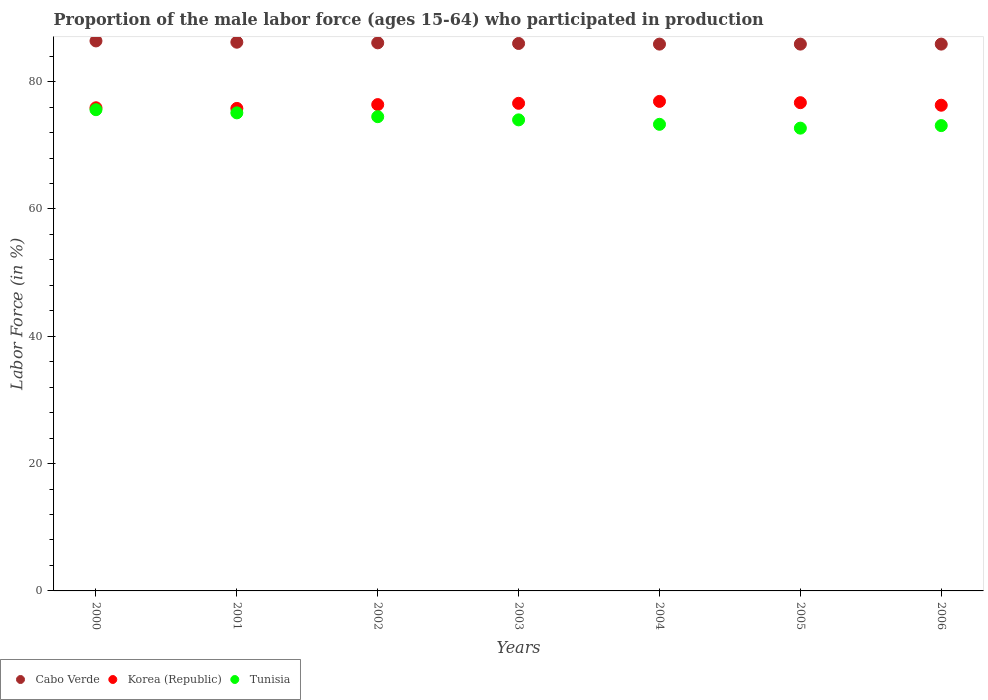Is the number of dotlines equal to the number of legend labels?
Your response must be concise. Yes. What is the proportion of the male labor force who participated in production in Tunisia in 2006?
Make the answer very short. 73.1. Across all years, what is the maximum proportion of the male labor force who participated in production in Cabo Verde?
Provide a succinct answer. 86.4. Across all years, what is the minimum proportion of the male labor force who participated in production in Korea (Republic)?
Provide a succinct answer. 75.8. What is the total proportion of the male labor force who participated in production in Tunisia in the graph?
Keep it short and to the point. 518.3. What is the difference between the proportion of the male labor force who participated in production in Cabo Verde in 2001 and that in 2006?
Your answer should be very brief. 0.3. What is the difference between the proportion of the male labor force who participated in production in Cabo Verde in 2005 and the proportion of the male labor force who participated in production in Korea (Republic) in 2000?
Provide a short and direct response. 10. What is the average proportion of the male labor force who participated in production in Tunisia per year?
Provide a short and direct response. 74.04. In the year 2004, what is the difference between the proportion of the male labor force who participated in production in Cabo Verde and proportion of the male labor force who participated in production in Korea (Republic)?
Your response must be concise. 9. In how many years, is the proportion of the male labor force who participated in production in Tunisia greater than 64 %?
Make the answer very short. 7. What is the ratio of the proportion of the male labor force who participated in production in Cabo Verde in 2000 to that in 2004?
Offer a very short reply. 1.01. What is the difference between the highest and the lowest proportion of the male labor force who participated in production in Cabo Verde?
Provide a short and direct response. 0.5. Is the sum of the proportion of the male labor force who participated in production in Tunisia in 2000 and 2004 greater than the maximum proportion of the male labor force who participated in production in Cabo Verde across all years?
Provide a short and direct response. Yes. Is it the case that in every year, the sum of the proportion of the male labor force who participated in production in Tunisia and proportion of the male labor force who participated in production in Korea (Republic)  is greater than the proportion of the male labor force who participated in production in Cabo Verde?
Make the answer very short. Yes. Is the proportion of the male labor force who participated in production in Korea (Republic) strictly less than the proportion of the male labor force who participated in production in Tunisia over the years?
Provide a succinct answer. No. How many dotlines are there?
Provide a short and direct response. 3. How many years are there in the graph?
Provide a succinct answer. 7. Are the values on the major ticks of Y-axis written in scientific E-notation?
Offer a very short reply. No. What is the title of the graph?
Provide a succinct answer. Proportion of the male labor force (ages 15-64) who participated in production. What is the label or title of the X-axis?
Provide a succinct answer. Years. What is the label or title of the Y-axis?
Give a very brief answer. Labor Force (in %). What is the Labor Force (in %) of Cabo Verde in 2000?
Offer a very short reply. 86.4. What is the Labor Force (in %) in Korea (Republic) in 2000?
Your answer should be very brief. 75.9. What is the Labor Force (in %) of Tunisia in 2000?
Provide a short and direct response. 75.6. What is the Labor Force (in %) of Cabo Verde in 2001?
Provide a short and direct response. 86.2. What is the Labor Force (in %) of Korea (Republic) in 2001?
Your answer should be compact. 75.8. What is the Labor Force (in %) in Tunisia in 2001?
Make the answer very short. 75.1. What is the Labor Force (in %) in Cabo Verde in 2002?
Provide a succinct answer. 86.1. What is the Labor Force (in %) in Korea (Republic) in 2002?
Offer a terse response. 76.4. What is the Labor Force (in %) of Tunisia in 2002?
Offer a very short reply. 74.5. What is the Labor Force (in %) in Korea (Republic) in 2003?
Your answer should be very brief. 76.6. What is the Labor Force (in %) in Tunisia in 2003?
Provide a short and direct response. 74. What is the Labor Force (in %) in Cabo Verde in 2004?
Keep it short and to the point. 85.9. What is the Labor Force (in %) of Korea (Republic) in 2004?
Give a very brief answer. 76.9. What is the Labor Force (in %) in Tunisia in 2004?
Keep it short and to the point. 73.3. What is the Labor Force (in %) in Cabo Verde in 2005?
Your answer should be very brief. 85.9. What is the Labor Force (in %) in Korea (Republic) in 2005?
Your answer should be very brief. 76.7. What is the Labor Force (in %) in Tunisia in 2005?
Ensure brevity in your answer.  72.7. What is the Labor Force (in %) in Cabo Verde in 2006?
Provide a short and direct response. 85.9. What is the Labor Force (in %) of Korea (Republic) in 2006?
Ensure brevity in your answer.  76.3. What is the Labor Force (in %) in Tunisia in 2006?
Offer a very short reply. 73.1. Across all years, what is the maximum Labor Force (in %) of Cabo Verde?
Offer a very short reply. 86.4. Across all years, what is the maximum Labor Force (in %) of Korea (Republic)?
Offer a terse response. 76.9. Across all years, what is the maximum Labor Force (in %) in Tunisia?
Your response must be concise. 75.6. Across all years, what is the minimum Labor Force (in %) in Cabo Verde?
Give a very brief answer. 85.9. Across all years, what is the minimum Labor Force (in %) of Korea (Republic)?
Make the answer very short. 75.8. Across all years, what is the minimum Labor Force (in %) in Tunisia?
Your response must be concise. 72.7. What is the total Labor Force (in %) of Cabo Verde in the graph?
Your answer should be very brief. 602.4. What is the total Labor Force (in %) in Korea (Republic) in the graph?
Provide a short and direct response. 534.6. What is the total Labor Force (in %) of Tunisia in the graph?
Your answer should be compact. 518.3. What is the difference between the Labor Force (in %) in Cabo Verde in 2000 and that in 2002?
Provide a short and direct response. 0.3. What is the difference between the Labor Force (in %) of Korea (Republic) in 2000 and that in 2002?
Provide a succinct answer. -0.5. What is the difference between the Labor Force (in %) of Tunisia in 2000 and that in 2002?
Offer a terse response. 1.1. What is the difference between the Labor Force (in %) in Cabo Verde in 2000 and that in 2004?
Offer a terse response. 0.5. What is the difference between the Labor Force (in %) in Tunisia in 2000 and that in 2004?
Offer a very short reply. 2.3. What is the difference between the Labor Force (in %) in Korea (Republic) in 2000 and that in 2005?
Your answer should be compact. -0.8. What is the difference between the Labor Force (in %) in Tunisia in 2000 and that in 2005?
Make the answer very short. 2.9. What is the difference between the Labor Force (in %) of Cabo Verde in 2000 and that in 2006?
Make the answer very short. 0.5. What is the difference between the Labor Force (in %) in Cabo Verde in 2001 and that in 2002?
Your answer should be compact. 0.1. What is the difference between the Labor Force (in %) of Korea (Republic) in 2001 and that in 2002?
Your answer should be very brief. -0.6. What is the difference between the Labor Force (in %) in Cabo Verde in 2001 and that in 2003?
Ensure brevity in your answer.  0.2. What is the difference between the Labor Force (in %) in Korea (Republic) in 2001 and that in 2003?
Offer a very short reply. -0.8. What is the difference between the Labor Force (in %) in Cabo Verde in 2001 and that in 2004?
Your answer should be very brief. 0.3. What is the difference between the Labor Force (in %) of Korea (Republic) in 2001 and that in 2004?
Offer a very short reply. -1.1. What is the difference between the Labor Force (in %) in Korea (Republic) in 2001 and that in 2005?
Make the answer very short. -0.9. What is the difference between the Labor Force (in %) in Tunisia in 2001 and that in 2005?
Provide a short and direct response. 2.4. What is the difference between the Labor Force (in %) in Korea (Republic) in 2001 and that in 2006?
Give a very brief answer. -0.5. What is the difference between the Labor Force (in %) of Tunisia in 2001 and that in 2006?
Make the answer very short. 2. What is the difference between the Labor Force (in %) in Korea (Republic) in 2002 and that in 2003?
Ensure brevity in your answer.  -0.2. What is the difference between the Labor Force (in %) of Korea (Republic) in 2002 and that in 2004?
Your answer should be compact. -0.5. What is the difference between the Labor Force (in %) in Tunisia in 2002 and that in 2004?
Keep it short and to the point. 1.2. What is the difference between the Labor Force (in %) in Cabo Verde in 2002 and that in 2005?
Keep it short and to the point. 0.2. What is the difference between the Labor Force (in %) in Korea (Republic) in 2002 and that in 2005?
Provide a succinct answer. -0.3. What is the difference between the Labor Force (in %) in Tunisia in 2002 and that in 2005?
Your answer should be very brief. 1.8. What is the difference between the Labor Force (in %) of Cabo Verde in 2002 and that in 2006?
Your answer should be very brief. 0.2. What is the difference between the Labor Force (in %) of Korea (Republic) in 2002 and that in 2006?
Offer a terse response. 0.1. What is the difference between the Labor Force (in %) of Cabo Verde in 2003 and that in 2004?
Give a very brief answer. 0.1. What is the difference between the Labor Force (in %) in Korea (Republic) in 2003 and that in 2004?
Make the answer very short. -0.3. What is the difference between the Labor Force (in %) in Tunisia in 2003 and that in 2004?
Provide a succinct answer. 0.7. What is the difference between the Labor Force (in %) of Tunisia in 2003 and that in 2005?
Provide a short and direct response. 1.3. What is the difference between the Labor Force (in %) in Korea (Republic) in 2003 and that in 2006?
Make the answer very short. 0.3. What is the difference between the Labor Force (in %) in Cabo Verde in 2004 and that in 2005?
Keep it short and to the point. 0. What is the difference between the Labor Force (in %) of Tunisia in 2004 and that in 2005?
Provide a short and direct response. 0.6. What is the difference between the Labor Force (in %) of Cabo Verde in 2004 and that in 2006?
Your response must be concise. 0. What is the difference between the Labor Force (in %) of Korea (Republic) in 2000 and the Labor Force (in %) of Tunisia in 2001?
Your answer should be very brief. 0.8. What is the difference between the Labor Force (in %) in Cabo Verde in 2000 and the Labor Force (in %) in Korea (Republic) in 2002?
Provide a short and direct response. 10. What is the difference between the Labor Force (in %) in Cabo Verde in 2000 and the Labor Force (in %) in Tunisia in 2002?
Provide a short and direct response. 11.9. What is the difference between the Labor Force (in %) in Cabo Verde in 2000 and the Labor Force (in %) in Korea (Republic) in 2004?
Make the answer very short. 9.5. What is the difference between the Labor Force (in %) in Korea (Republic) in 2000 and the Labor Force (in %) in Tunisia in 2005?
Provide a succinct answer. 3.2. What is the difference between the Labor Force (in %) in Cabo Verde in 2000 and the Labor Force (in %) in Korea (Republic) in 2006?
Your response must be concise. 10.1. What is the difference between the Labor Force (in %) of Korea (Republic) in 2000 and the Labor Force (in %) of Tunisia in 2006?
Make the answer very short. 2.8. What is the difference between the Labor Force (in %) of Cabo Verde in 2001 and the Labor Force (in %) of Tunisia in 2002?
Give a very brief answer. 11.7. What is the difference between the Labor Force (in %) in Cabo Verde in 2001 and the Labor Force (in %) in Tunisia in 2003?
Make the answer very short. 12.2. What is the difference between the Labor Force (in %) in Korea (Republic) in 2001 and the Labor Force (in %) in Tunisia in 2003?
Provide a short and direct response. 1.8. What is the difference between the Labor Force (in %) in Cabo Verde in 2001 and the Labor Force (in %) in Korea (Republic) in 2004?
Your response must be concise. 9.3. What is the difference between the Labor Force (in %) in Cabo Verde in 2001 and the Labor Force (in %) in Tunisia in 2004?
Make the answer very short. 12.9. What is the difference between the Labor Force (in %) of Korea (Republic) in 2001 and the Labor Force (in %) of Tunisia in 2005?
Give a very brief answer. 3.1. What is the difference between the Labor Force (in %) of Cabo Verde in 2001 and the Labor Force (in %) of Korea (Republic) in 2006?
Your answer should be compact. 9.9. What is the difference between the Labor Force (in %) in Cabo Verde in 2001 and the Labor Force (in %) in Tunisia in 2006?
Offer a terse response. 13.1. What is the difference between the Labor Force (in %) in Korea (Republic) in 2001 and the Labor Force (in %) in Tunisia in 2006?
Your answer should be very brief. 2.7. What is the difference between the Labor Force (in %) in Cabo Verde in 2002 and the Labor Force (in %) in Korea (Republic) in 2003?
Your answer should be very brief. 9.5. What is the difference between the Labor Force (in %) in Cabo Verde in 2002 and the Labor Force (in %) in Korea (Republic) in 2004?
Offer a very short reply. 9.2. What is the difference between the Labor Force (in %) in Cabo Verde in 2002 and the Labor Force (in %) in Tunisia in 2004?
Your response must be concise. 12.8. What is the difference between the Labor Force (in %) of Korea (Republic) in 2002 and the Labor Force (in %) of Tunisia in 2004?
Keep it short and to the point. 3.1. What is the difference between the Labor Force (in %) of Cabo Verde in 2002 and the Labor Force (in %) of Tunisia in 2005?
Ensure brevity in your answer.  13.4. What is the difference between the Labor Force (in %) in Korea (Republic) in 2002 and the Labor Force (in %) in Tunisia in 2005?
Keep it short and to the point. 3.7. What is the difference between the Labor Force (in %) in Cabo Verde in 2003 and the Labor Force (in %) in Tunisia in 2004?
Provide a short and direct response. 12.7. What is the difference between the Labor Force (in %) of Korea (Republic) in 2003 and the Labor Force (in %) of Tunisia in 2004?
Your response must be concise. 3.3. What is the difference between the Labor Force (in %) of Korea (Republic) in 2003 and the Labor Force (in %) of Tunisia in 2005?
Your answer should be very brief. 3.9. What is the difference between the Labor Force (in %) of Cabo Verde in 2003 and the Labor Force (in %) of Korea (Republic) in 2006?
Your response must be concise. 9.7. What is the difference between the Labor Force (in %) in Cabo Verde in 2003 and the Labor Force (in %) in Tunisia in 2006?
Your answer should be compact. 12.9. What is the difference between the Labor Force (in %) of Korea (Republic) in 2004 and the Labor Force (in %) of Tunisia in 2005?
Offer a very short reply. 4.2. What is the difference between the Labor Force (in %) of Cabo Verde in 2004 and the Labor Force (in %) of Korea (Republic) in 2006?
Your answer should be very brief. 9.6. What is the difference between the Labor Force (in %) in Cabo Verde in 2004 and the Labor Force (in %) in Tunisia in 2006?
Your answer should be very brief. 12.8. What is the average Labor Force (in %) of Cabo Verde per year?
Your answer should be compact. 86.06. What is the average Labor Force (in %) of Korea (Republic) per year?
Provide a short and direct response. 76.37. What is the average Labor Force (in %) of Tunisia per year?
Provide a short and direct response. 74.04. In the year 2000, what is the difference between the Labor Force (in %) of Cabo Verde and Labor Force (in %) of Korea (Republic)?
Give a very brief answer. 10.5. In the year 2001, what is the difference between the Labor Force (in %) in Cabo Verde and Labor Force (in %) in Korea (Republic)?
Offer a very short reply. 10.4. In the year 2001, what is the difference between the Labor Force (in %) of Korea (Republic) and Labor Force (in %) of Tunisia?
Ensure brevity in your answer.  0.7. In the year 2002, what is the difference between the Labor Force (in %) of Cabo Verde and Labor Force (in %) of Korea (Republic)?
Your answer should be compact. 9.7. In the year 2002, what is the difference between the Labor Force (in %) of Korea (Republic) and Labor Force (in %) of Tunisia?
Offer a very short reply. 1.9. In the year 2003, what is the difference between the Labor Force (in %) in Cabo Verde and Labor Force (in %) in Korea (Republic)?
Provide a succinct answer. 9.4. In the year 2003, what is the difference between the Labor Force (in %) in Korea (Republic) and Labor Force (in %) in Tunisia?
Offer a terse response. 2.6. In the year 2004, what is the difference between the Labor Force (in %) of Korea (Republic) and Labor Force (in %) of Tunisia?
Provide a short and direct response. 3.6. In the year 2005, what is the difference between the Labor Force (in %) of Cabo Verde and Labor Force (in %) of Korea (Republic)?
Offer a very short reply. 9.2. In the year 2005, what is the difference between the Labor Force (in %) in Korea (Republic) and Labor Force (in %) in Tunisia?
Your answer should be compact. 4. In the year 2006, what is the difference between the Labor Force (in %) of Cabo Verde and Labor Force (in %) of Korea (Republic)?
Keep it short and to the point. 9.6. In the year 2006, what is the difference between the Labor Force (in %) of Korea (Republic) and Labor Force (in %) of Tunisia?
Your answer should be very brief. 3.2. What is the ratio of the Labor Force (in %) in Cabo Verde in 2000 to that in 2001?
Provide a succinct answer. 1. What is the ratio of the Labor Force (in %) of Korea (Republic) in 2000 to that in 2001?
Give a very brief answer. 1. What is the ratio of the Labor Force (in %) in Tunisia in 2000 to that in 2001?
Give a very brief answer. 1.01. What is the ratio of the Labor Force (in %) of Korea (Republic) in 2000 to that in 2002?
Make the answer very short. 0.99. What is the ratio of the Labor Force (in %) of Tunisia in 2000 to that in 2002?
Provide a succinct answer. 1.01. What is the ratio of the Labor Force (in %) in Cabo Verde in 2000 to that in 2003?
Make the answer very short. 1. What is the ratio of the Labor Force (in %) in Korea (Republic) in 2000 to that in 2003?
Your response must be concise. 0.99. What is the ratio of the Labor Force (in %) in Tunisia in 2000 to that in 2003?
Your response must be concise. 1.02. What is the ratio of the Labor Force (in %) of Cabo Verde in 2000 to that in 2004?
Offer a terse response. 1.01. What is the ratio of the Labor Force (in %) in Tunisia in 2000 to that in 2004?
Offer a very short reply. 1.03. What is the ratio of the Labor Force (in %) of Korea (Republic) in 2000 to that in 2005?
Offer a terse response. 0.99. What is the ratio of the Labor Force (in %) in Tunisia in 2000 to that in 2005?
Your response must be concise. 1.04. What is the ratio of the Labor Force (in %) in Tunisia in 2000 to that in 2006?
Your response must be concise. 1.03. What is the ratio of the Labor Force (in %) in Korea (Republic) in 2001 to that in 2002?
Your answer should be very brief. 0.99. What is the ratio of the Labor Force (in %) in Tunisia in 2001 to that in 2002?
Make the answer very short. 1.01. What is the ratio of the Labor Force (in %) of Cabo Verde in 2001 to that in 2003?
Your response must be concise. 1. What is the ratio of the Labor Force (in %) in Korea (Republic) in 2001 to that in 2003?
Offer a terse response. 0.99. What is the ratio of the Labor Force (in %) of Tunisia in 2001 to that in 2003?
Offer a very short reply. 1.01. What is the ratio of the Labor Force (in %) in Cabo Verde in 2001 to that in 2004?
Ensure brevity in your answer.  1. What is the ratio of the Labor Force (in %) in Korea (Republic) in 2001 to that in 2004?
Keep it short and to the point. 0.99. What is the ratio of the Labor Force (in %) of Tunisia in 2001 to that in 2004?
Provide a succinct answer. 1.02. What is the ratio of the Labor Force (in %) in Cabo Verde in 2001 to that in 2005?
Your answer should be compact. 1. What is the ratio of the Labor Force (in %) in Korea (Republic) in 2001 to that in 2005?
Your answer should be compact. 0.99. What is the ratio of the Labor Force (in %) of Tunisia in 2001 to that in 2005?
Your answer should be compact. 1.03. What is the ratio of the Labor Force (in %) in Cabo Verde in 2001 to that in 2006?
Your answer should be very brief. 1. What is the ratio of the Labor Force (in %) in Tunisia in 2001 to that in 2006?
Provide a short and direct response. 1.03. What is the ratio of the Labor Force (in %) in Cabo Verde in 2002 to that in 2003?
Provide a succinct answer. 1. What is the ratio of the Labor Force (in %) in Korea (Republic) in 2002 to that in 2003?
Ensure brevity in your answer.  1. What is the ratio of the Labor Force (in %) in Tunisia in 2002 to that in 2003?
Offer a very short reply. 1.01. What is the ratio of the Labor Force (in %) in Cabo Verde in 2002 to that in 2004?
Provide a short and direct response. 1. What is the ratio of the Labor Force (in %) of Tunisia in 2002 to that in 2004?
Offer a very short reply. 1.02. What is the ratio of the Labor Force (in %) of Korea (Republic) in 2002 to that in 2005?
Offer a very short reply. 1. What is the ratio of the Labor Force (in %) of Tunisia in 2002 to that in 2005?
Offer a terse response. 1.02. What is the ratio of the Labor Force (in %) of Tunisia in 2002 to that in 2006?
Provide a succinct answer. 1.02. What is the ratio of the Labor Force (in %) of Cabo Verde in 2003 to that in 2004?
Offer a terse response. 1. What is the ratio of the Labor Force (in %) of Tunisia in 2003 to that in 2004?
Provide a short and direct response. 1.01. What is the ratio of the Labor Force (in %) in Cabo Verde in 2003 to that in 2005?
Keep it short and to the point. 1. What is the ratio of the Labor Force (in %) in Korea (Republic) in 2003 to that in 2005?
Provide a short and direct response. 1. What is the ratio of the Labor Force (in %) in Tunisia in 2003 to that in 2005?
Offer a very short reply. 1.02. What is the ratio of the Labor Force (in %) in Cabo Verde in 2003 to that in 2006?
Make the answer very short. 1. What is the ratio of the Labor Force (in %) of Korea (Republic) in 2003 to that in 2006?
Your answer should be very brief. 1. What is the ratio of the Labor Force (in %) of Tunisia in 2003 to that in 2006?
Offer a terse response. 1.01. What is the ratio of the Labor Force (in %) of Cabo Verde in 2004 to that in 2005?
Make the answer very short. 1. What is the ratio of the Labor Force (in %) in Tunisia in 2004 to that in 2005?
Offer a terse response. 1.01. What is the ratio of the Labor Force (in %) of Cabo Verde in 2004 to that in 2006?
Make the answer very short. 1. What is the ratio of the Labor Force (in %) of Korea (Republic) in 2004 to that in 2006?
Provide a short and direct response. 1.01. What is the ratio of the Labor Force (in %) of Tunisia in 2004 to that in 2006?
Provide a short and direct response. 1. What is the ratio of the Labor Force (in %) in Tunisia in 2005 to that in 2006?
Provide a short and direct response. 0.99. What is the difference between the highest and the lowest Labor Force (in %) in Cabo Verde?
Provide a succinct answer. 0.5. 